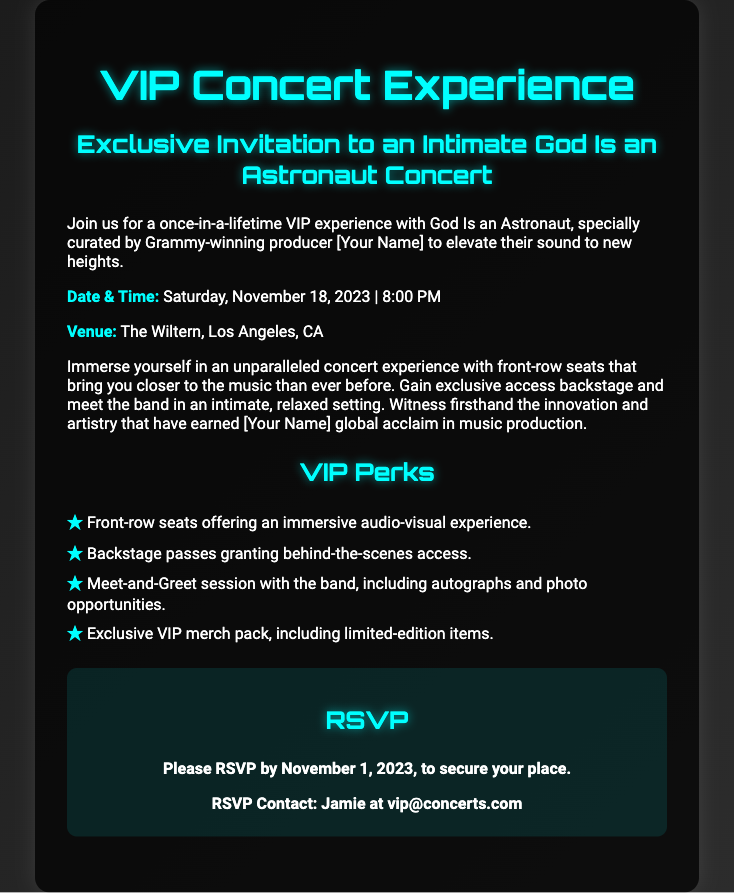Where is the concert taking place? The venue for the concert is mentioned in the document.
Answer: The Wiltern, Los Angeles, CA What benefits are included with the VIP perks? The VIP perks section lists several benefits, highlighting exclusive experiences.
Answer: Front-row seats, backstage passes, meet-and-greet session, exclusive VIP merch pack When is the RSVP deadline? The document clearly states the last date to RSVP in order to secure a place.
Answer: November 1, 2023 Who should be contacted for RSVP? The RSVP contact information is provided in the RSVP section of the document.
Answer: Jamie at vip@concerts.com What is the purpose of the document? The main objective of the document is to invite guests to a special concert experience.
Answer: VIP Concert Experience RSVP Why would someone want to attend this concert? The reasoning involves the unique experience and exclusive access provided to attendees.
Answer: Intimate experience with God Is an Astronaut, meet-and-greet, front-row seats 